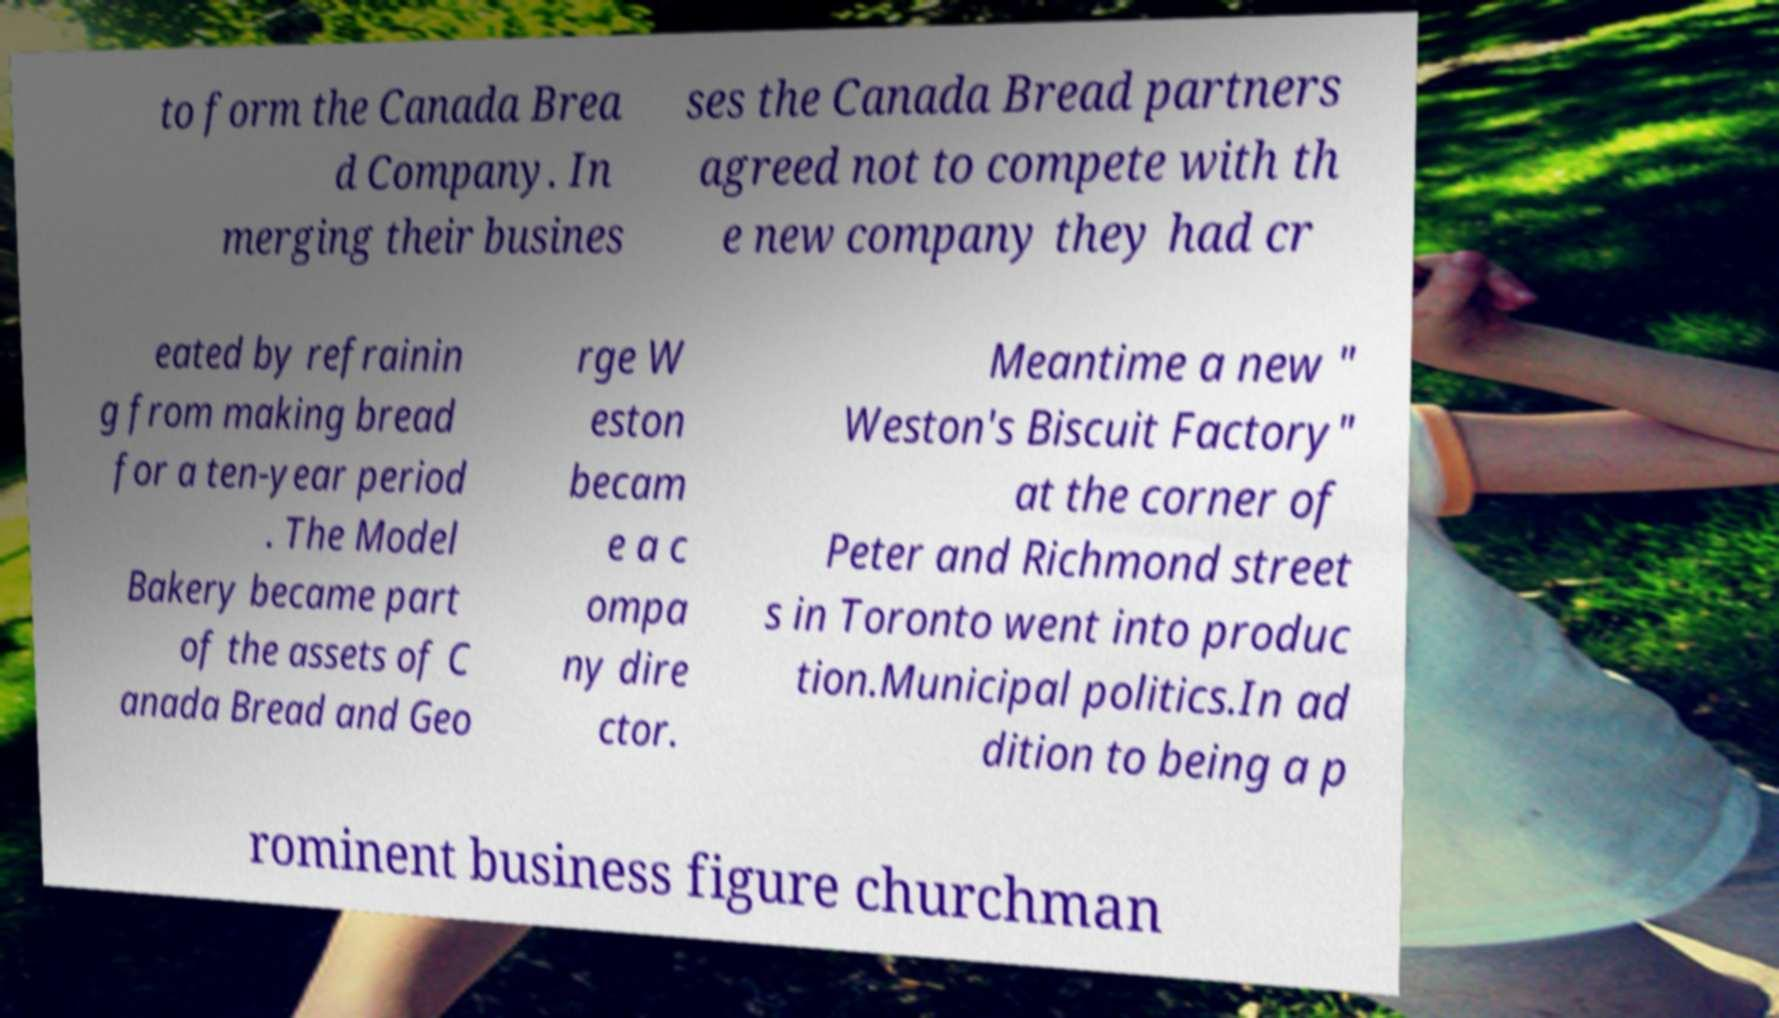Can you accurately transcribe the text from the provided image for me? to form the Canada Brea d Company. In merging their busines ses the Canada Bread partners agreed not to compete with th e new company they had cr eated by refrainin g from making bread for a ten-year period . The Model Bakery became part of the assets of C anada Bread and Geo rge W eston becam e a c ompa ny dire ctor. Meantime a new " Weston's Biscuit Factory" at the corner of Peter and Richmond street s in Toronto went into produc tion.Municipal politics.In ad dition to being a p rominent business figure churchman 